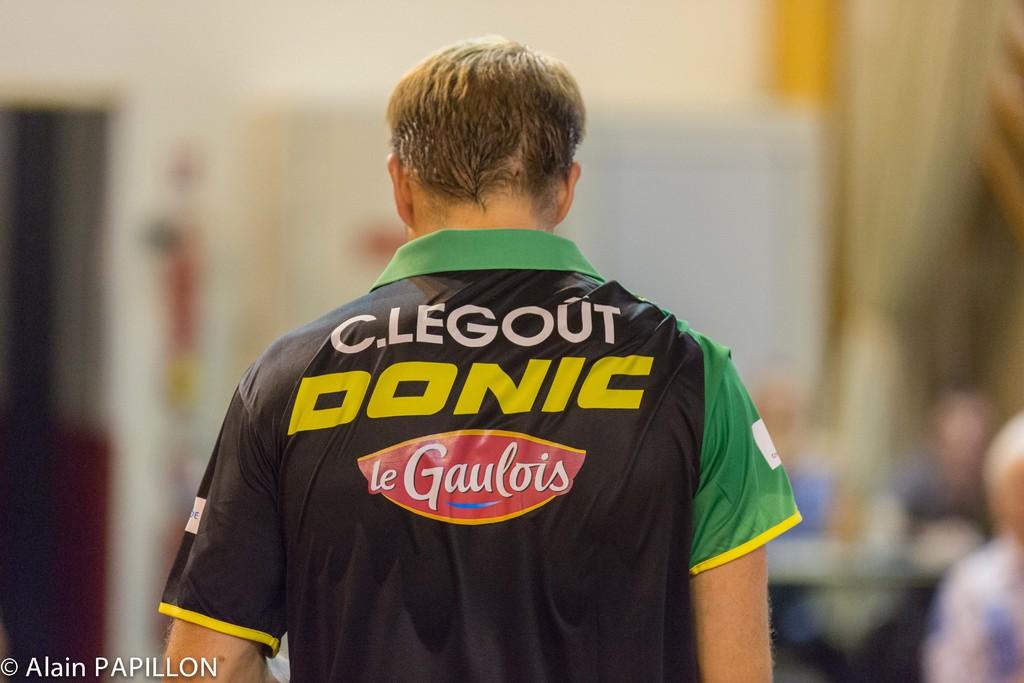What brand is seen on this jersey?
Offer a terse response. Le gaulois. 